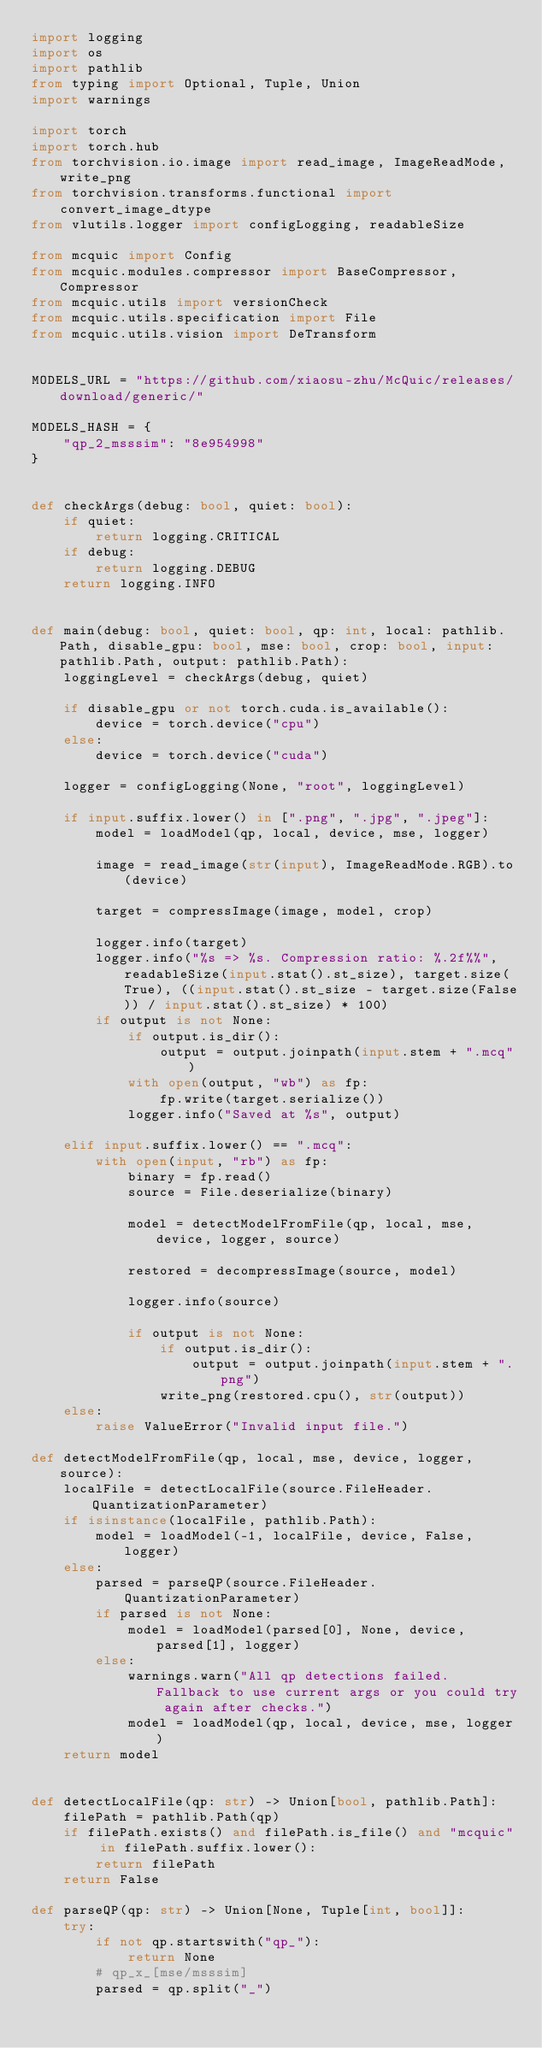Convert code to text. <code><loc_0><loc_0><loc_500><loc_500><_Python_>import logging
import os
import pathlib
from typing import Optional, Tuple, Union
import warnings

import torch
import torch.hub
from torchvision.io.image import read_image, ImageReadMode, write_png
from torchvision.transforms.functional import convert_image_dtype
from vlutils.logger import configLogging, readableSize

from mcquic import Config
from mcquic.modules.compressor import BaseCompressor, Compressor
from mcquic.utils import versionCheck
from mcquic.utils.specification import File
from mcquic.utils.vision import DeTransform


MODELS_URL = "https://github.com/xiaosu-zhu/McQuic/releases/download/generic/"

MODELS_HASH = {
    "qp_2_msssim": "8e954998"
}


def checkArgs(debug: bool, quiet: bool):
    if quiet:
        return logging.CRITICAL
    if debug:
        return logging.DEBUG
    return logging.INFO


def main(debug: bool, quiet: bool, qp: int, local: pathlib.Path, disable_gpu: bool, mse: bool, crop: bool, input: pathlib.Path, output: pathlib.Path):
    loggingLevel = checkArgs(debug, quiet)

    if disable_gpu or not torch.cuda.is_available():
        device = torch.device("cpu")
    else:
        device = torch.device("cuda")

    logger = configLogging(None, "root", loggingLevel)

    if input.suffix.lower() in [".png", ".jpg", ".jpeg"]:
        model = loadModel(qp, local, device, mse, logger)

        image = read_image(str(input), ImageReadMode.RGB).to(device)

        target = compressImage(image, model, crop)

        logger.info(target)
        logger.info("%s => %s. Compression ratio: %.2f%%", readableSize(input.stat().st_size), target.size(True), ((input.stat().st_size - target.size(False)) / input.stat().st_size) * 100)
        if output is not None:
            if output.is_dir():
                output = output.joinpath(input.stem + ".mcq")
            with open(output, "wb") as fp:
                fp.write(target.serialize())
            logger.info("Saved at %s", output)

    elif input.suffix.lower() == ".mcq":
        with open(input, "rb") as fp:
            binary = fp.read()
            source = File.deserialize(binary)

            model = detectModelFromFile(qp, local, mse, device, logger, source)

            restored = decompressImage(source, model)

            logger.info(source)

            if output is not None:
                if output.is_dir():
                    output = output.joinpath(input.stem + ".png")
                write_png(restored.cpu(), str(output))
    else:
        raise ValueError("Invalid input file.")

def detectModelFromFile(qp, local, mse, device, logger, source):
    localFile = detectLocalFile(source.FileHeader.QuantizationParameter)
    if isinstance(localFile, pathlib.Path):
        model = loadModel(-1, localFile, device, False, logger)
    else:
        parsed = parseQP(source.FileHeader.QuantizationParameter)
        if parsed is not None:
            model = loadModel(parsed[0], None, device, parsed[1], logger)
        else:
            warnings.warn("All qp detections failed. Fallback to use current args or you could try again after checks.")
            model = loadModel(qp, local, device, mse, logger)
    return model


def detectLocalFile(qp: str) -> Union[bool, pathlib.Path]:
    filePath = pathlib.Path(qp)
    if filePath.exists() and filePath.is_file() and "mcquic" in filePath.suffix.lower():
        return filePath
    return False

def parseQP(qp: str) -> Union[None, Tuple[int, bool]]:
    try:
        if not qp.startswith("qp_"):
            return None
        # qp_x_[mse/msssim]
        parsed = qp.split("_")</code> 